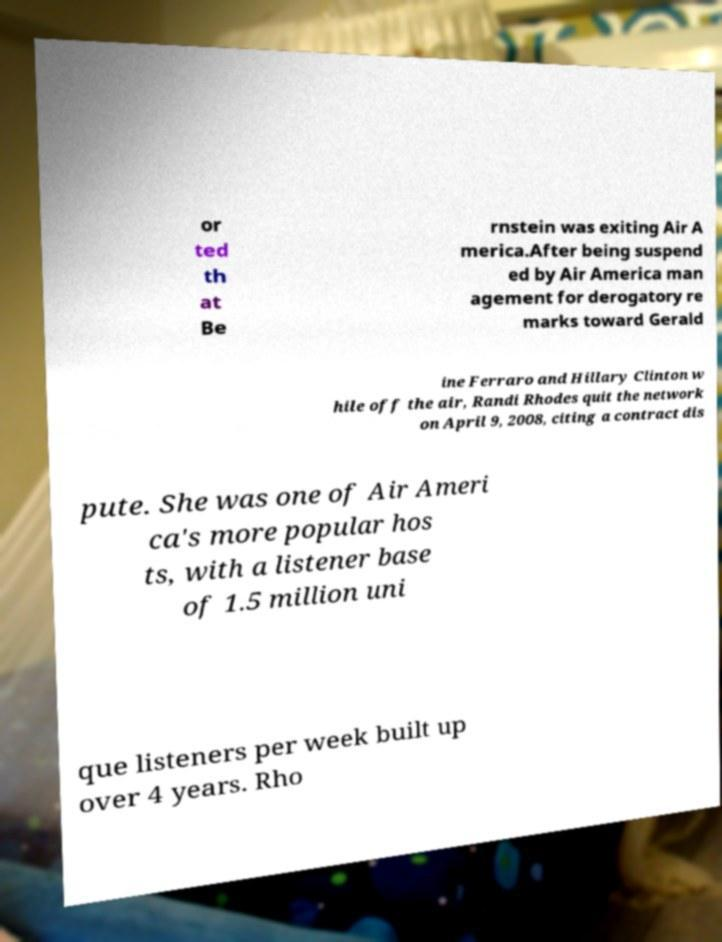Please identify and transcribe the text found in this image. or ted th at Be rnstein was exiting Air A merica.After being suspend ed by Air America man agement for derogatory re marks toward Gerald ine Ferraro and Hillary Clinton w hile off the air, Randi Rhodes quit the network on April 9, 2008, citing a contract dis pute. She was one of Air Ameri ca's more popular hos ts, with a listener base of 1.5 million uni que listeners per week built up over 4 years. Rho 